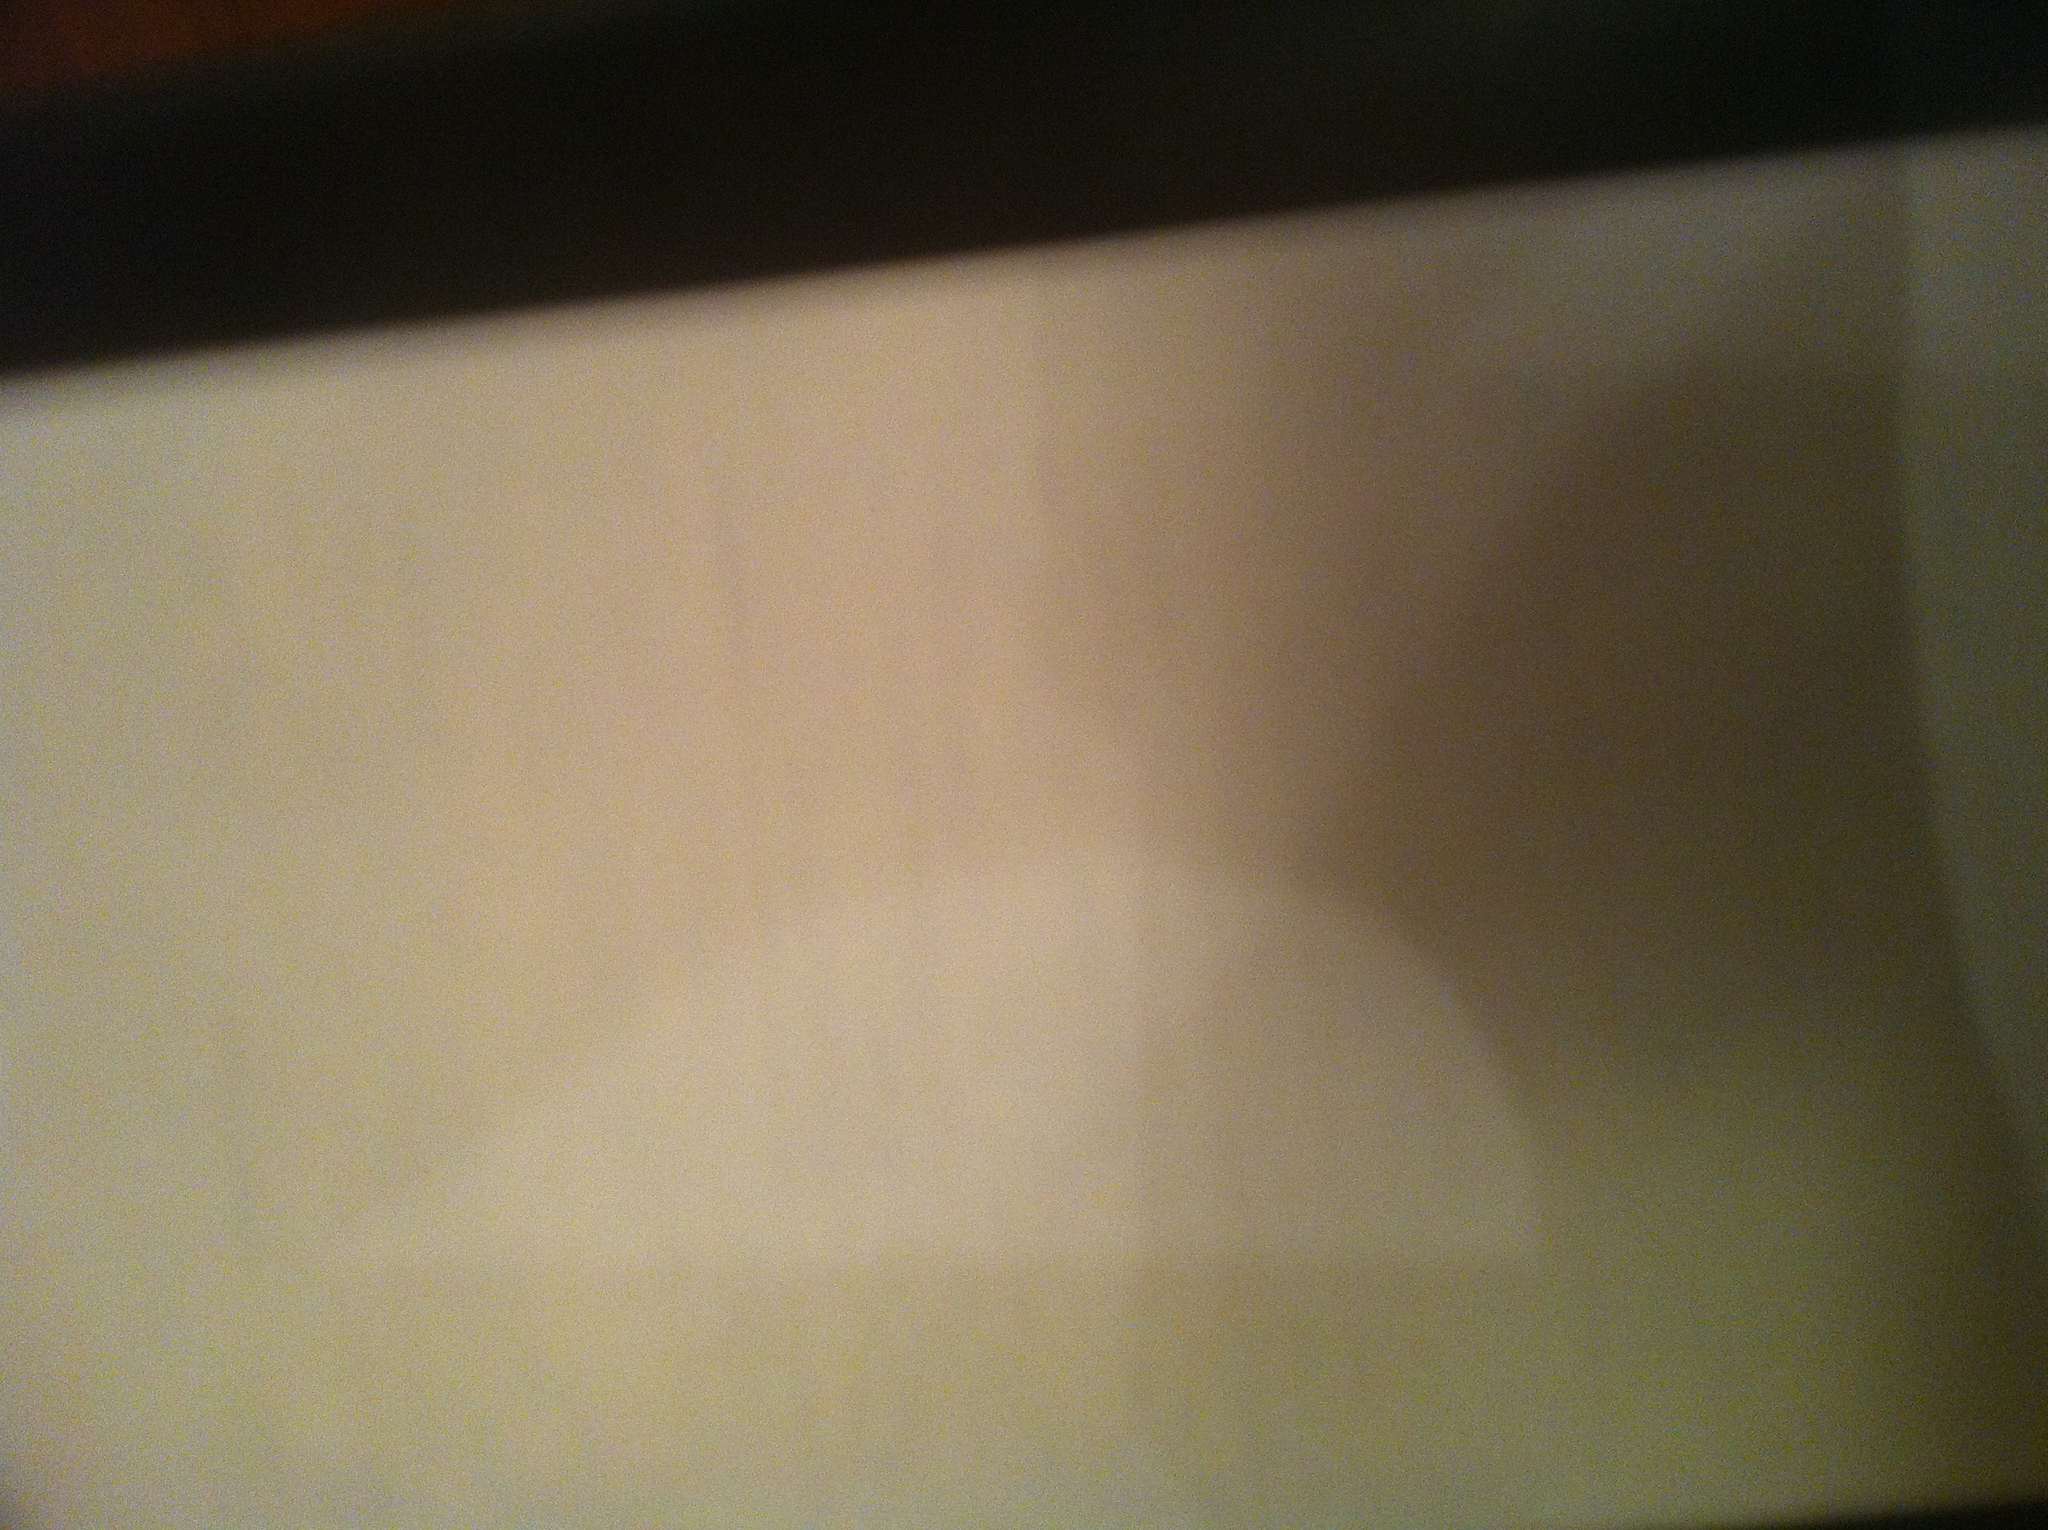Can you describe what you see in this image? The image appears to be a close-up of a piece of paper, possibly a receipt, but the content is not clearly visible. The lighting and angle make it difficult to read any text or details. Do you think there is any important information on this piece of paper? Given that it looks like a piece of paper, it's possible it contains important information like a receipt or a document. However, without being able to read the text, it's hard to say for certain. What could have caused the blurriness in this image? The blurriness in the image could be due to a number of factors such as a shaky camera, poor focus, low lighting, or movement while taking the photo. It could also be influenced by the camera quality or settings. Imagine that this piece of paper contains a secret message from a spy. What could the message say? If this piece of paper contained a secret message from a spy, it might say something like, 'Meet at the designated location at midnight. The package will be delivered by an inconspicuous courier. Use the red codeword for verification. Destroy this message immediately after reading.' Can you create a short story about how this receipt might be important in a corporate espionage case? In a bustling corporate world, every detail matters. The receipt, crumpled and nearly forgotten, held more than just a purchase list. It was a key piece of evidence planted by an insider whistleblower. An unsuspecting employee, Eve, picked it up thinking it was her own. Days later, while cleaning her desk, she noticed a cryptic QR code on it and scanned it out of curiosity. To her surprise, it revealed confidential documents exposing a major fraud scheme involving top executives. Little did she know, she was about to uncover a scandal that would shake the corporate world to its core, making that seemingly innocent receipt the cornerstone of a massive investigation. 